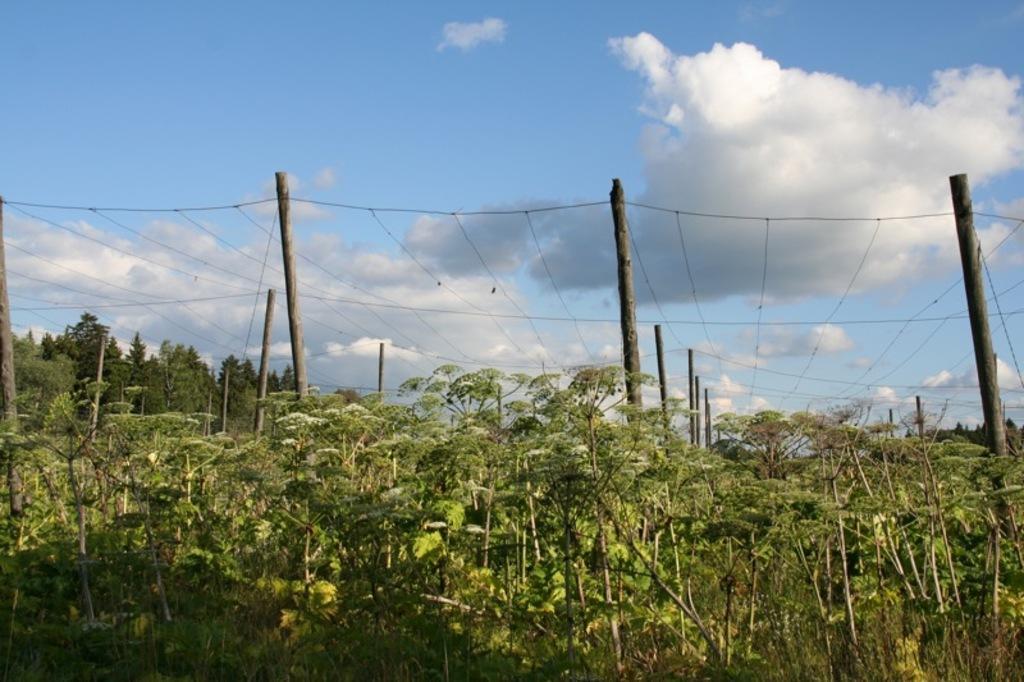How would you summarize this image in a sentence or two? In this image there are some plants in the bottom of this image and there are some trees on the left side of this image. There are some bamboos are attached with some ropes in the middle of this image. There is a cloudy sky on the top of this image. 